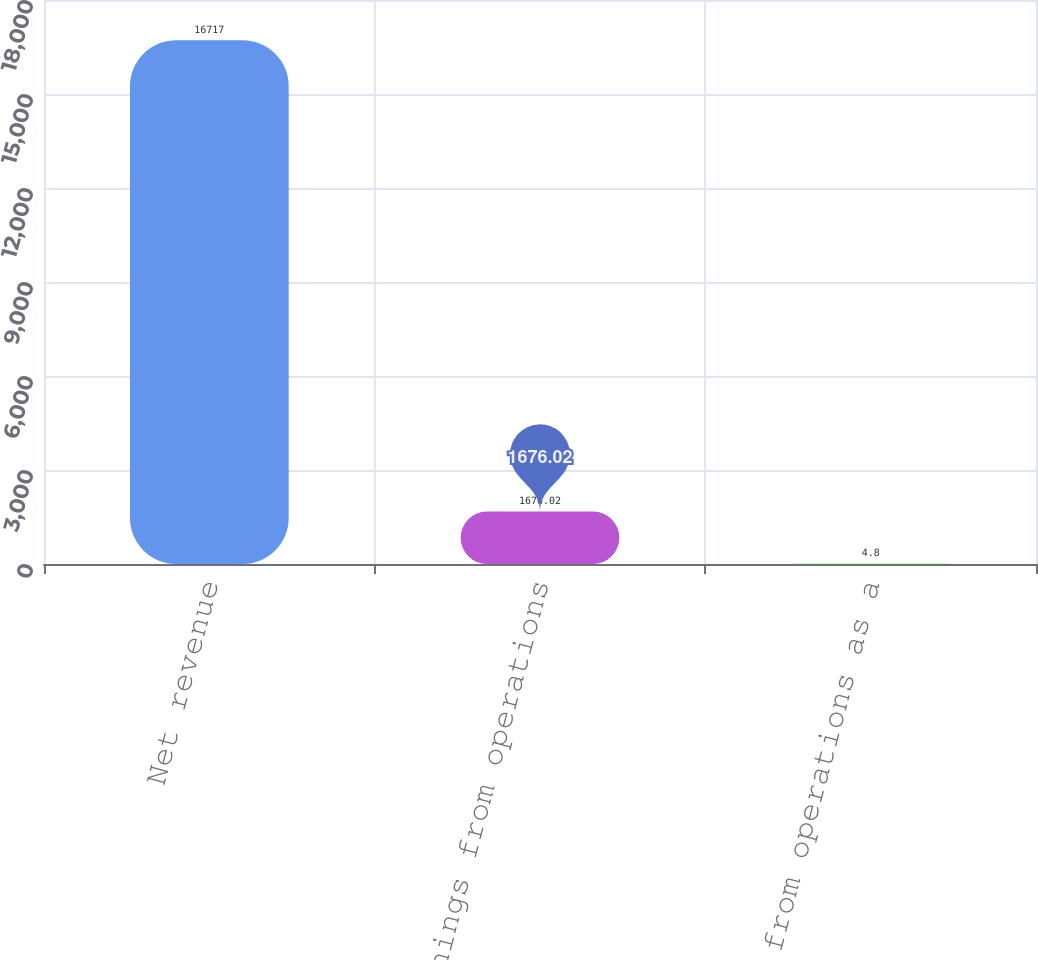Convert chart. <chart><loc_0><loc_0><loc_500><loc_500><bar_chart><fcel>Net revenue<fcel>Earnings from operations<fcel>Earnings from operations as a<nl><fcel>16717<fcel>1676.02<fcel>4.8<nl></chart> 